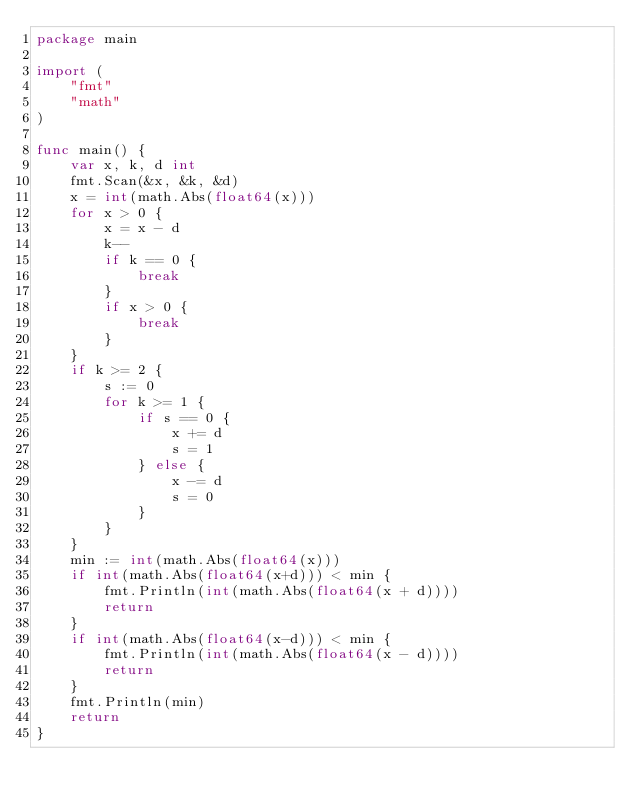Convert code to text. <code><loc_0><loc_0><loc_500><loc_500><_Go_>package main

import (
	"fmt"
	"math"
)

func main() {
	var x, k, d int
	fmt.Scan(&x, &k, &d)
	x = int(math.Abs(float64(x)))
	for x > 0 {
		x = x - d
		k--
		if k == 0 {
			break
		}
		if x > 0 {
			break
		}
	}
	if k >= 2 {
		s := 0
		for k >= 1 {
			if s == 0 {
				x += d
				s = 1
			} else {
				x -= d
				s = 0
			}
		}
	}
	min := int(math.Abs(float64(x)))
	if int(math.Abs(float64(x+d))) < min {
		fmt.Println(int(math.Abs(float64(x + d))))
		return
	}
	if int(math.Abs(float64(x-d))) < min {
		fmt.Println(int(math.Abs(float64(x - d))))
		return
	}
	fmt.Println(min)
	return
}
</code> 